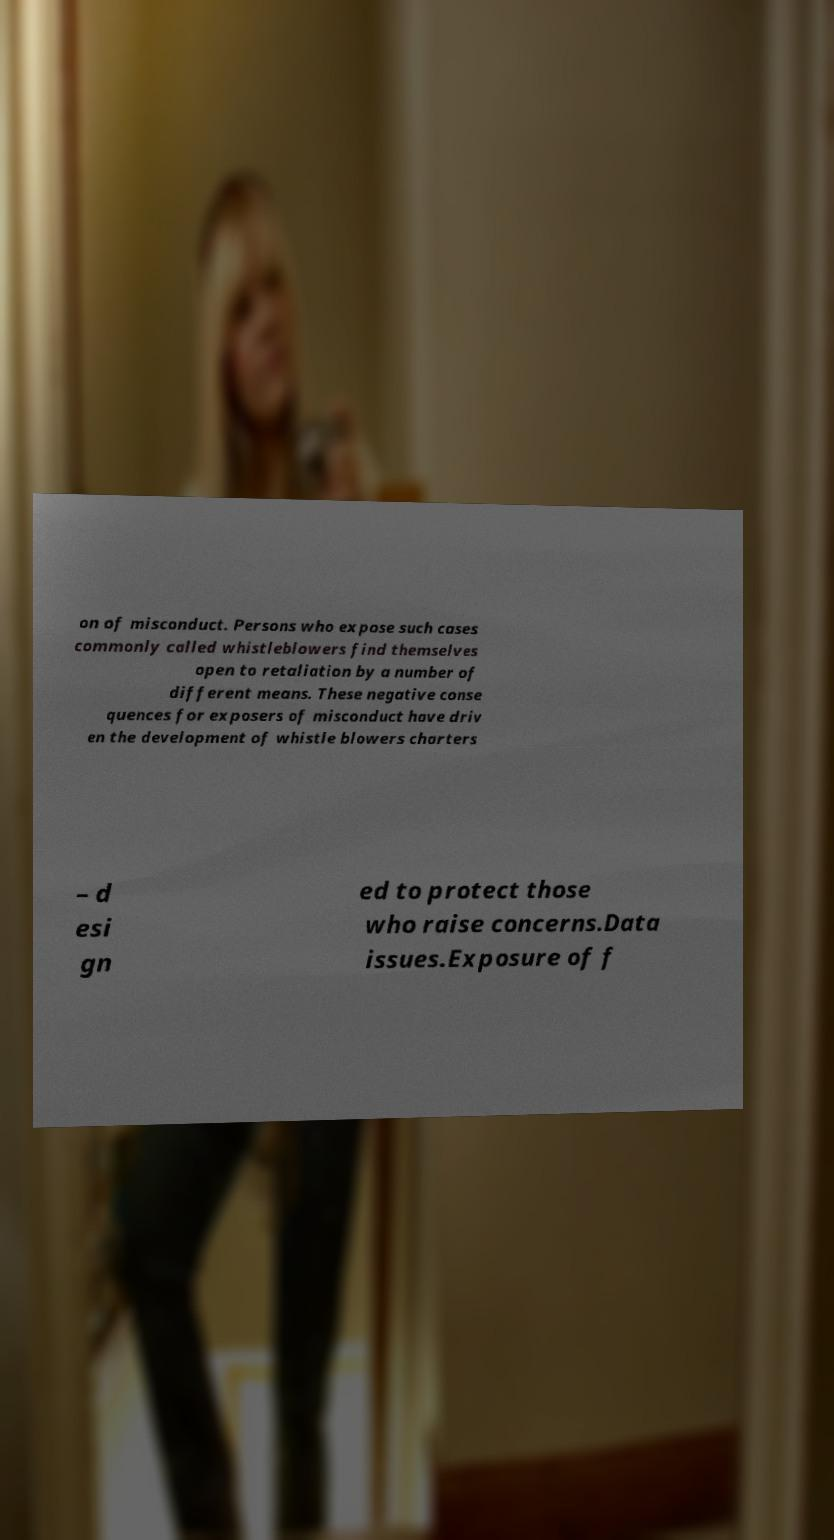Can you accurately transcribe the text from the provided image for me? on of misconduct. Persons who expose such cases commonly called whistleblowers find themselves open to retaliation by a number of different means. These negative conse quences for exposers of misconduct have driv en the development of whistle blowers charters – d esi gn ed to protect those who raise concerns.Data issues.Exposure of f 